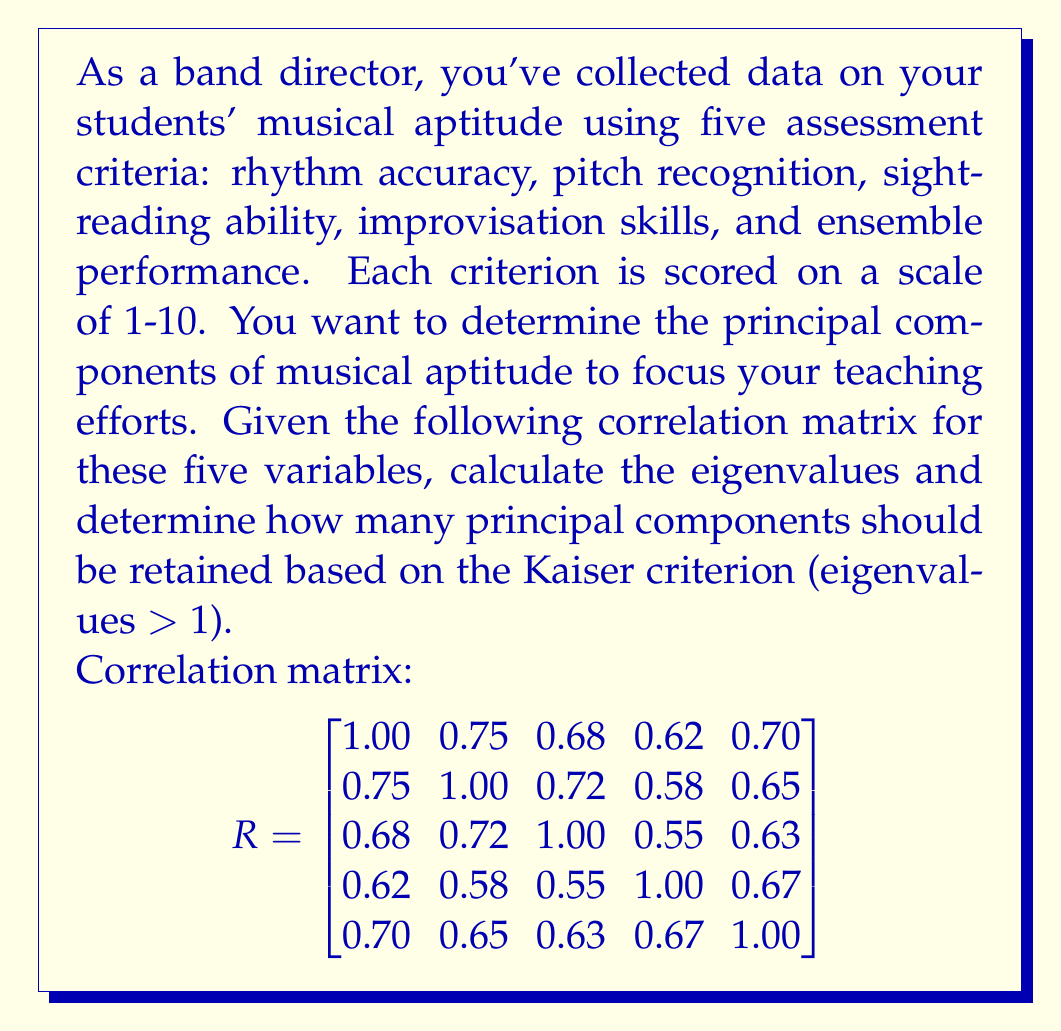Teach me how to tackle this problem. To determine the principal components, we need to find the eigenvalues of the correlation matrix. The steps are as follows:

1) First, we need to solve the characteristic equation:
   $\det(R - \lambda I) = 0$

2) Expanding this determinant gives us a 5th-degree polynomial in $\lambda$:
   $\lambda^5 - 5\lambda^4 + 8.3839\lambda^3 - 6.8655\lambda^2 + 2.7816\lambda - 0.4459 = 0$

3) Solving this equation (typically using numerical methods) gives us the eigenvalues:
   $\lambda_1 \approx 3.5246$
   $\lambda_2 \approx 0.5754$
   $\lambda_3 \approx 0.3789$
   $\lambda_4 \approx 0.2910$
   $\lambda_5 \approx 0.2301$

4) The Kaiser criterion states that we should retain principal components with eigenvalues greater than 1.

5) In this case, only the first eigenvalue ($\lambda_1 \approx 3.5246$) is greater than 1.

Therefore, based on the Kaiser criterion, we should retain only one principal component.

This suggests that there is one dominant factor underlying musical aptitude as measured by these five criteria. This principal component likely represents a general musical ability that influences performance across all five assessment areas.
Answer: We should retain 1 principal component based on the Kaiser criterion. 